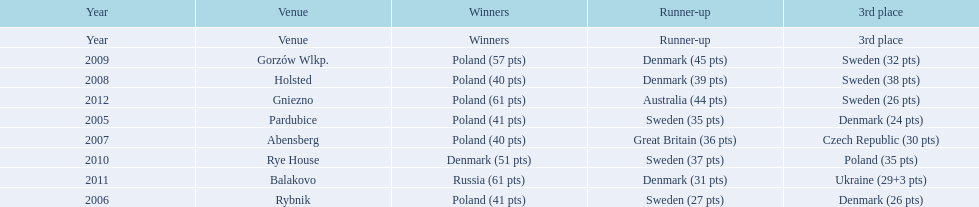After enjoying five consecutive victories at the team speedway junior world championship poland was finally unseated in what year? 2010. In that year, what teams placed first through third? Denmark (51 pts), Sweden (37 pts), Poland (35 pts). Which of those positions did poland specifically place in? 3rd place. 